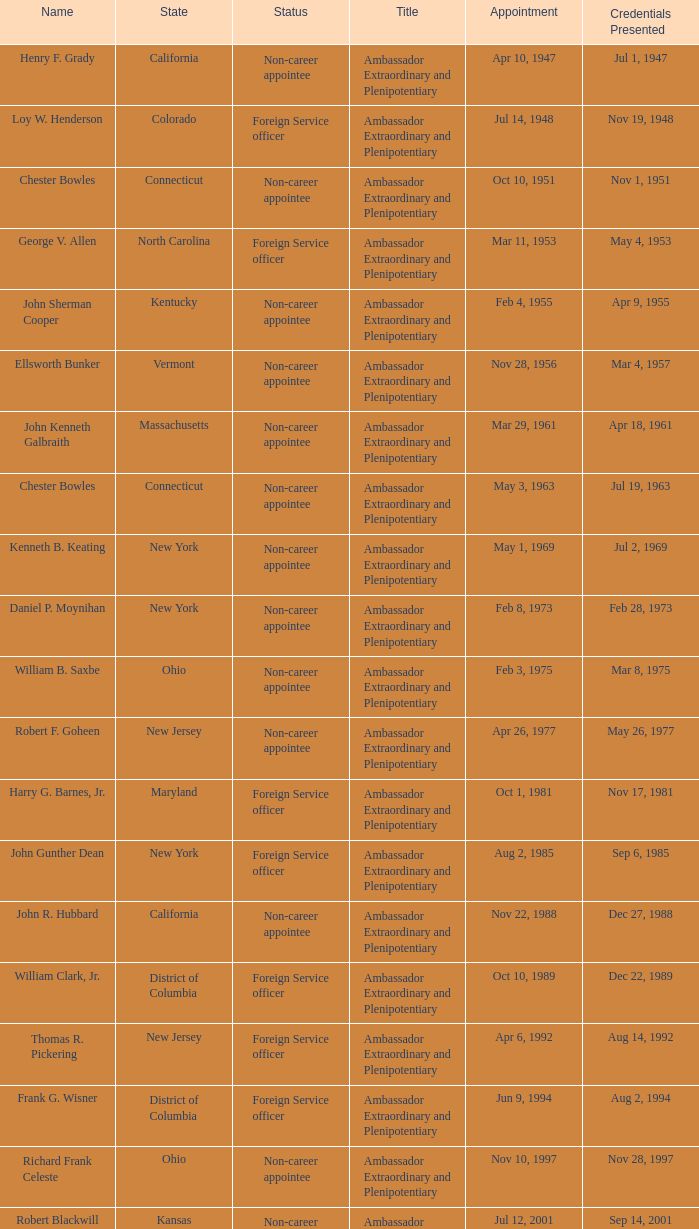What day was the appointment when Credentials Presented was jul 2, 1969? May 1, 1969. Could you parse the entire table as a dict? {'header': ['Name', 'State', 'Status', 'Title', 'Appointment', 'Credentials Presented'], 'rows': [['Henry F. Grady', 'California', 'Non-career appointee', 'Ambassador Extraordinary and Plenipotentiary', 'Apr 10, 1947', 'Jul 1, 1947'], ['Loy W. Henderson', 'Colorado', 'Foreign Service officer', 'Ambassador Extraordinary and Plenipotentiary', 'Jul 14, 1948', 'Nov 19, 1948'], ['Chester Bowles', 'Connecticut', 'Non-career appointee', 'Ambassador Extraordinary and Plenipotentiary', 'Oct 10, 1951', 'Nov 1, 1951'], ['George V. Allen', 'North Carolina', 'Foreign Service officer', 'Ambassador Extraordinary and Plenipotentiary', 'Mar 11, 1953', 'May 4, 1953'], ['John Sherman Cooper', 'Kentucky', 'Non-career appointee', 'Ambassador Extraordinary and Plenipotentiary', 'Feb 4, 1955', 'Apr 9, 1955'], ['Ellsworth Bunker', 'Vermont', 'Non-career appointee', 'Ambassador Extraordinary and Plenipotentiary', 'Nov 28, 1956', 'Mar 4, 1957'], ['John Kenneth Galbraith', 'Massachusetts', 'Non-career appointee', 'Ambassador Extraordinary and Plenipotentiary', 'Mar 29, 1961', 'Apr 18, 1961'], ['Chester Bowles', 'Connecticut', 'Non-career appointee', 'Ambassador Extraordinary and Plenipotentiary', 'May 3, 1963', 'Jul 19, 1963'], ['Kenneth B. Keating', 'New York', 'Non-career appointee', 'Ambassador Extraordinary and Plenipotentiary', 'May 1, 1969', 'Jul 2, 1969'], ['Daniel P. Moynihan', 'New York', 'Non-career appointee', 'Ambassador Extraordinary and Plenipotentiary', 'Feb 8, 1973', 'Feb 28, 1973'], ['William B. Saxbe', 'Ohio', 'Non-career appointee', 'Ambassador Extraordinary and Plenipotentiary', 'Feb 3, 1975', 'Mar 8, 1975'], ['Robert F. Goheen', 'New Jersey', 'Non-career appointee', 'Ambassador Extraordinary and Plenipotentiary', 'Apr 26, 1977', 'May 26, 1977'], ['Harry G. Barnes, Jr.', 'Maryland', 'Foreign Service officer', 'Ambassador Extraordinary and Plenipotentiary', 'Oct 1, 1981', 'Nov 17, 1981'], ['John Gunther Dean', 'New York', 'Foreign Service officer', 'Ambassador Extraordinary and Plenipotentiary', 'Aug 2, 1985', 'Sep 6, 1985'], ['John R. Hubbard', 'California', 'Non-career appointee', 'Ambassador Extraordinary and Plenipotentiary', 'Nov 22, 1988', 'Dec 27, 1988'], ['William Clark, Jr.', 'District of Columbia', 'Foreign Service officer', 'Ambassador Extraordinary and Plenipotentiary', 'Oct 10, 1989', 'Dec 22, 1989'], ['Thomas R. Pickering', 'New Jersey', 'Foreign Service officer', 'Ambassador Extraordinary and Plenipotentiary', 'Apr 6, 1992', 'Aug 14, 1992'], ['Frank G. Wisner', 'District of Columbia', 'Foreign Service officer', 'Ambassador Extraordinary and Plenipotentiary', 'Jun 9, 1994', 'Aug 2, 1994'], ['Richard Frank Celeste', 'Ohio', 'Non-career appointee', 'Ambassador Extraordinary and Plenipotentiary', 'Nov 10, 1997', 'Nov 28, 1997'], ['Robert Blackwill', 'Kansas', 'Non-career appointee', 'Ambassador Extraordinary and Plenipotentiary', 'Jul 12, 2001', 'Sep 14, 2001'], ['David Campbell Mulford', 'Illinois', 'Non-career officer', 'Ambassador Extraordinary and Plenipotentiary', 'Dec 12, 2003', 'Feb 23, 2004'], ['Timothy J. Roemer', 'Indiana', 'Non-career appointee', 'Ambassador Extraordinary and Plenipotentiary', 'Jul 23, 2009', 'Aug 11, 2009'], ['Albert Peter Burleigh', 'California', 'Foreign Service officer', "Charge d'affaires", 'June 2011', 'Left post 2012'], ['Nancy Jo Powell', 'Iowa', 'Foreign Service officer', 'Ambassador Extraordinary and Plenipotentiary', 'February 7, 2012', 'April 19, 2012']]} 